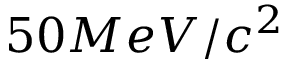<formula> <loc_0><loc_0><loc_500><loc_500>5 0 M e V / c ^ { 2 }</formula> 